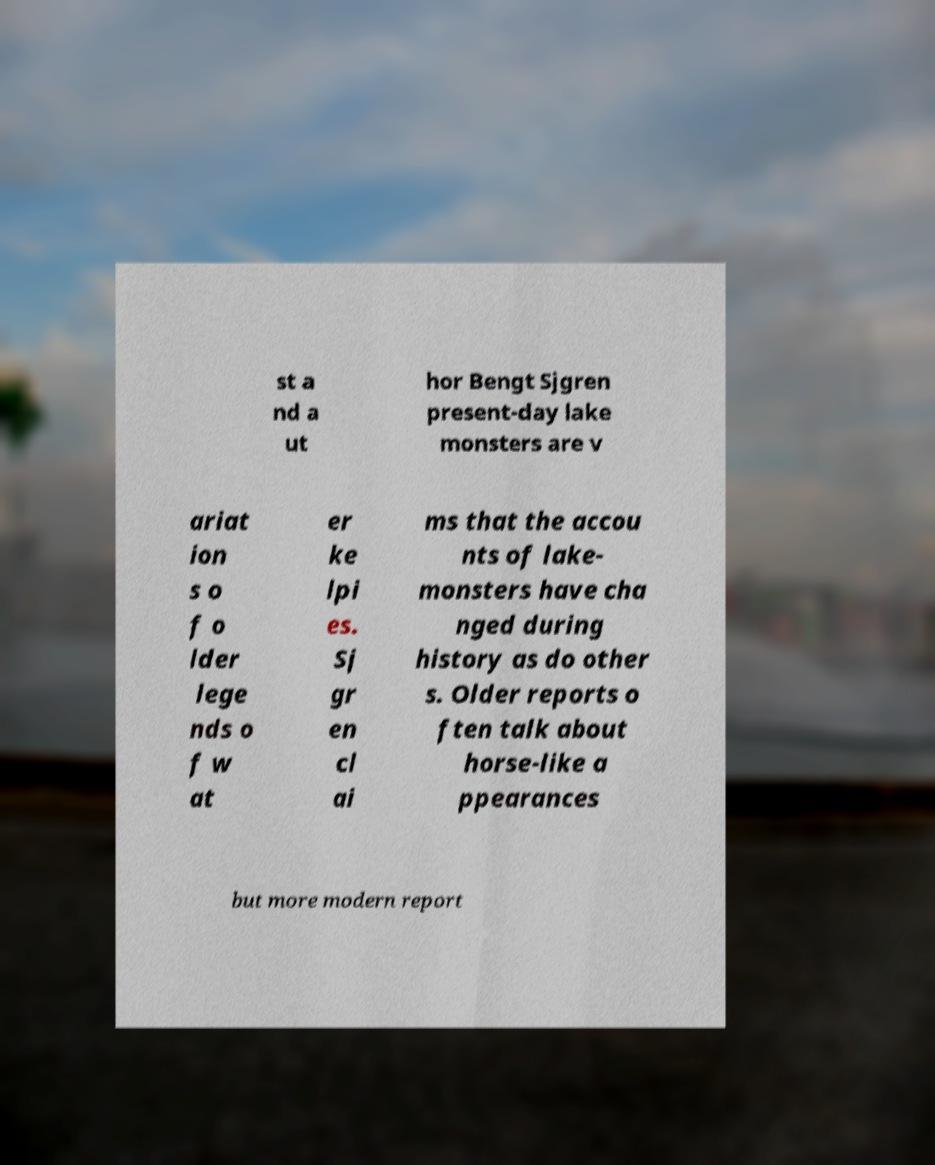There's text embedded in this image that I need extracted. Can you transcribe it verbatim? st a nd a ut hor Bengt Sjgren present-day lake monsters are v ariat ion s o f o lder lege nds o f w at er ke lpi es. Sj gr en cl ai ms that the accou nts of lake- monsters have cha nged during history as do other s. Older reports o ften talk about horse-like a ppearances but more modern report 